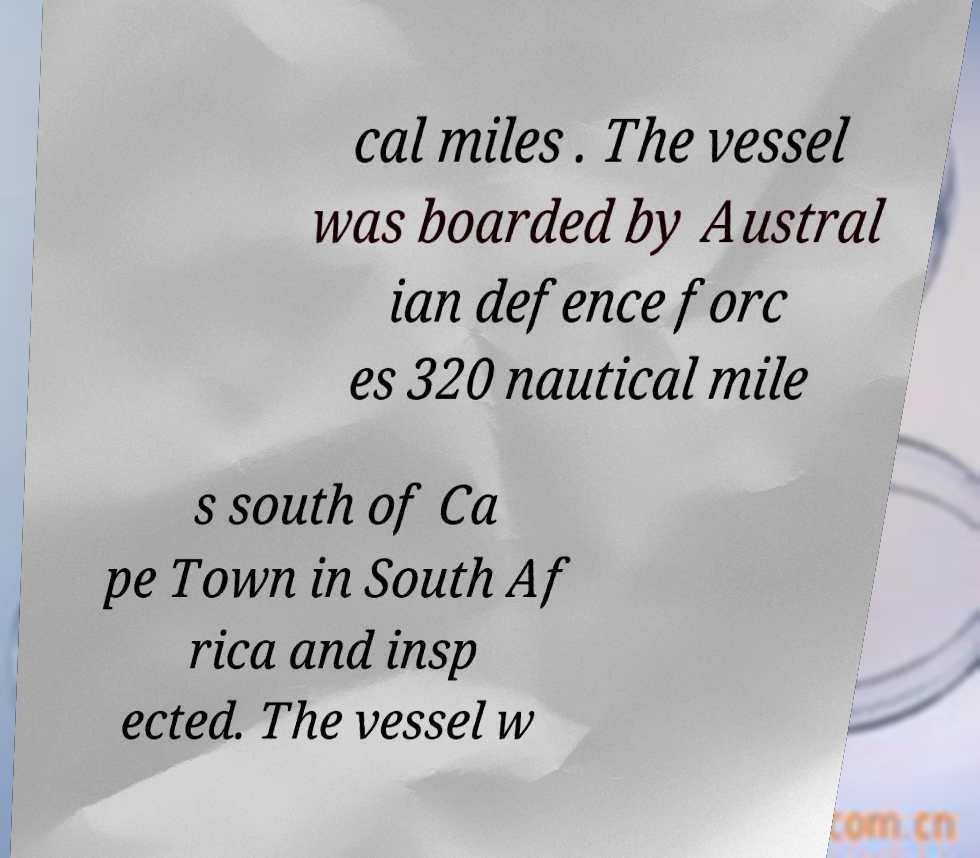What messages or text are displayed in this image? I need them in a readable, typed format. cal miles . The vessel was boarded by Austral ian defence forc es 320 nautical mile s south of Ca pe Town in South Af rica and insp ected. The vessel w 